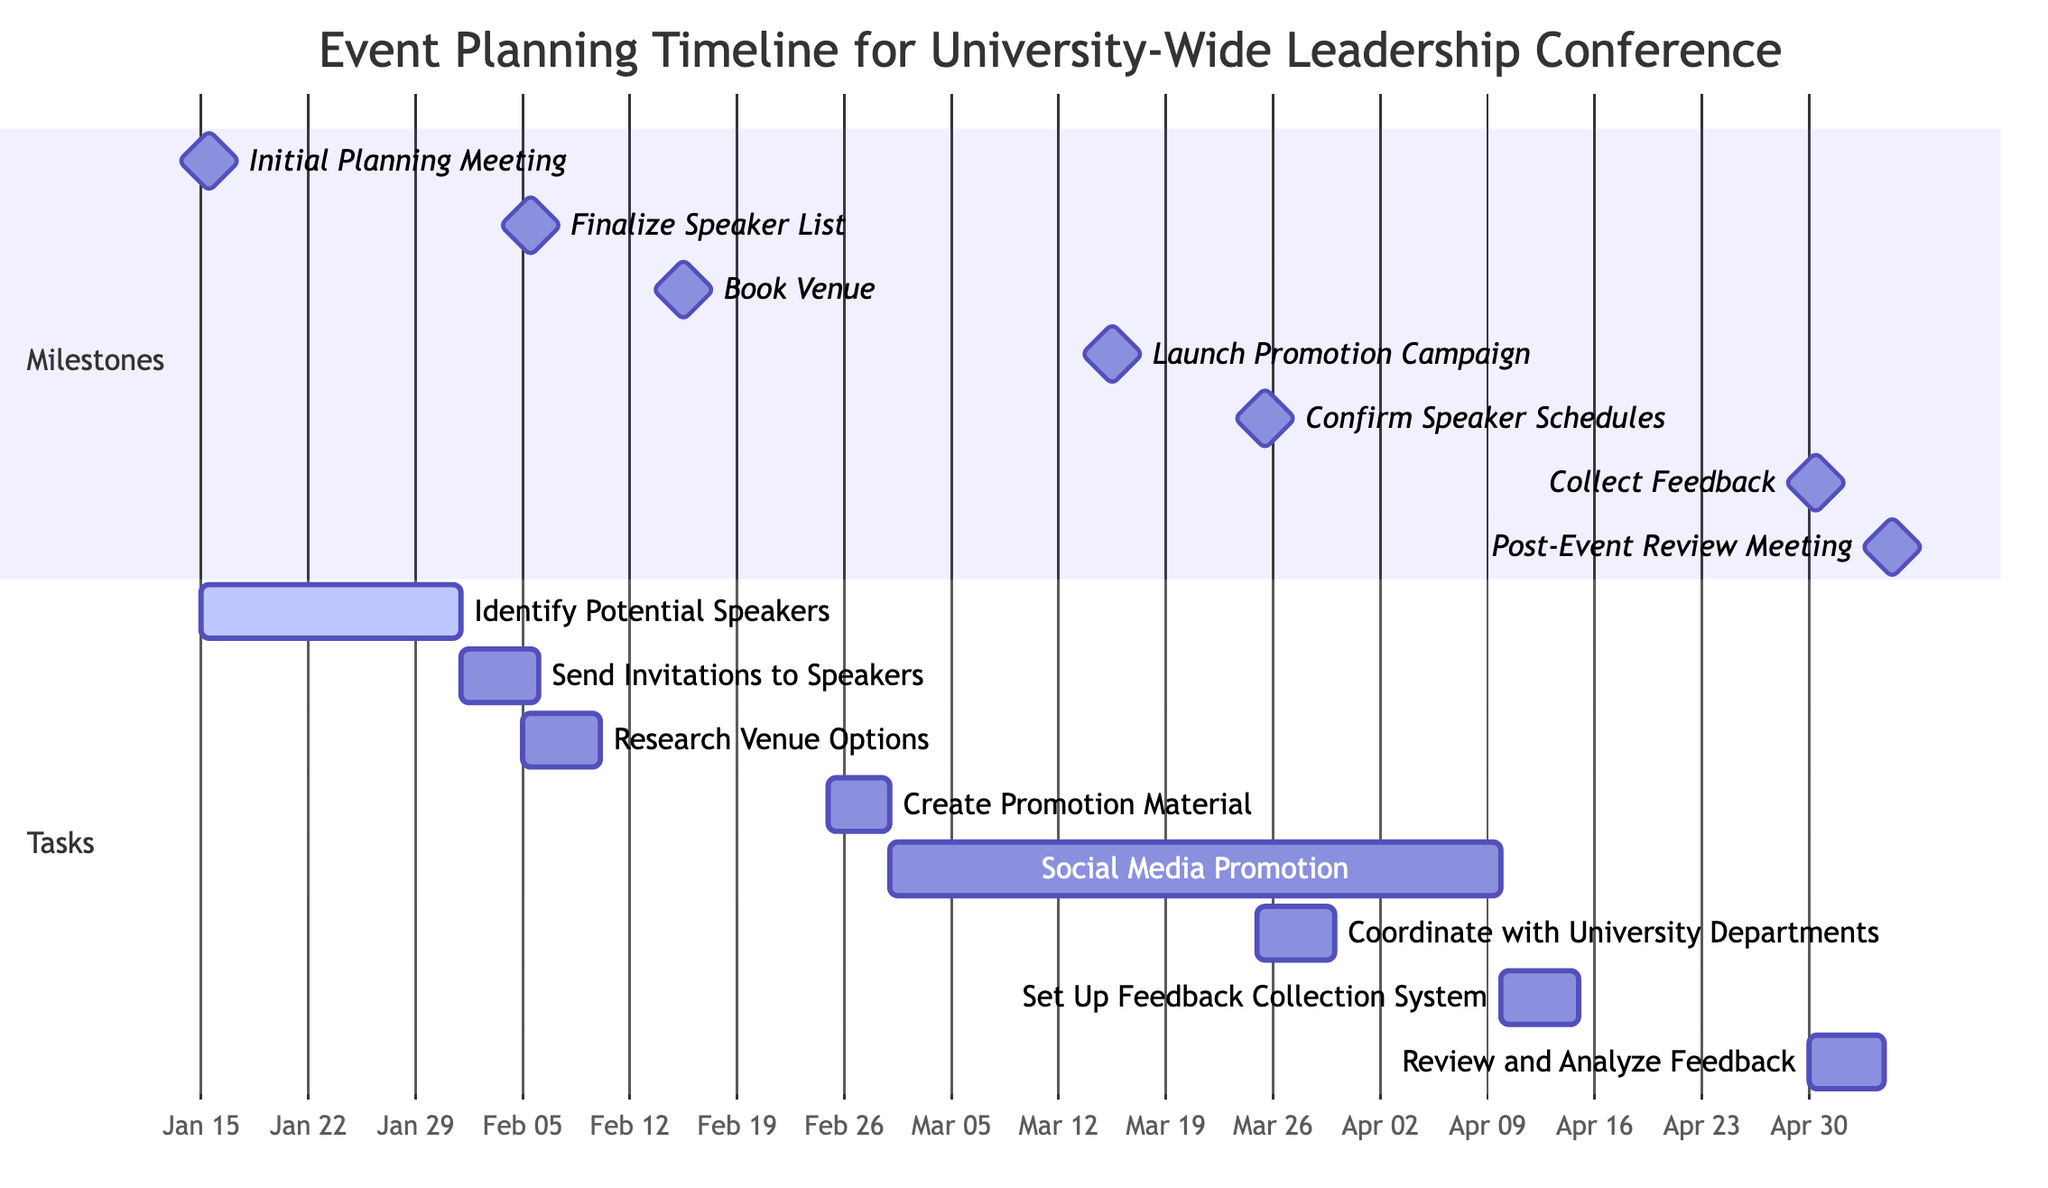What is the duration of the "Launch Promotion Campaign"? The "Launch Promotion Campaign" starts on March 1, 2023, and ends on March 15, 2023. The duration is from the start date to the end date, which is 15 days.
Answer: 15 days Which task is associated with the "Finalize Speaker List"? The "Finalize Speaker List" milestone is associated with the task "Send Invitations to Speakers," which starts after the milestone is completed.
Answer: Send Invitations to Speakers How many tasks depend on the "Initial Planning Meeting"? The diagram shows two tasks: "Identify Potential Speakers" and "Research Venue Options" that depend on the "Initial Planning Meeting." Therefore, there are two tasks.
Answer: 2 tasks What is the start date for the "Review and Analyze Feedback" task? This task is listed in the diagram and begins on April 30, 2023, following the end of the "Collect Feedback" phase.
Answer: April 30, 2023 Which task follows after the "Create Promotion Material"? In the flow of the diagram, the task following "Create Promotion Material" is "Social Media Promotion," which starts immediately after the materials are created.
Answer: Social Media Promotion What is the end date for the "Book Venue" milestone? The "Book Venue" milestone is specified to end on February 15, 2023, which is directly stated in the timeline.
Answer: February 15, 2023 How many total milestones are there in the diagram? The diagram includes a total of seven milestones labeled as distinct events in the planning process. Therefore, there are seven milestones.
Answer: 7 milestones What task begins immediately after "Confirm Speaker Schedules"? According to the dependencies outlined in the diagram, the task "Coordinate with University Departments" begins straight after "Confirm Speaker Schedules" is completed.
Answer: Coordinate with University Departments What is the overall theme of this Gantt chart? The overall theme of the Gantt chart revolves around the timeline and management of tasks related to planning a Leadership Conference at a university, including speaker scheduling and event promotion.
Answer: Event Planning Timeline for University-Wide Leadership Conference 